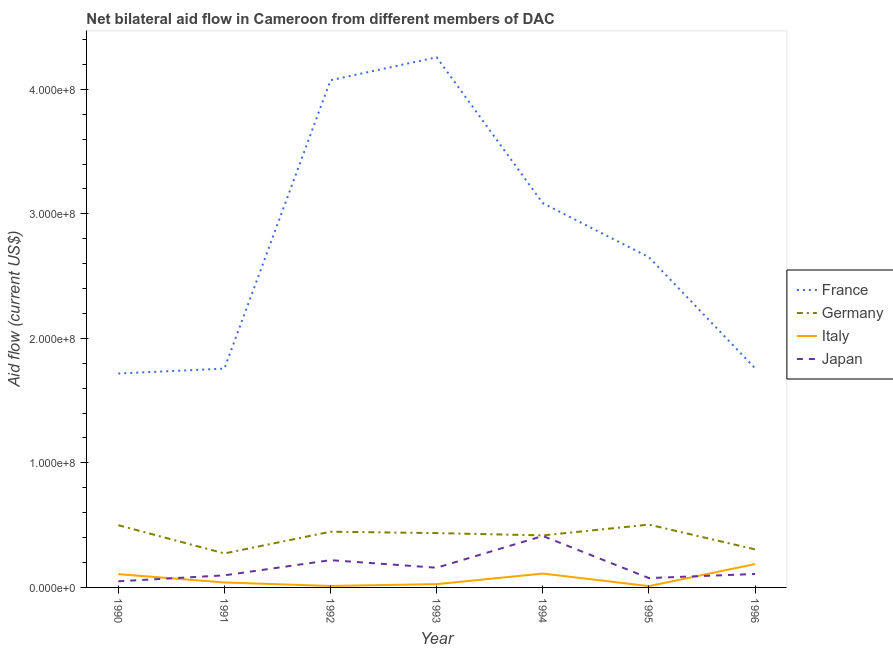How many different coloured lines are there?
Your answer should be very brief. 4. Does the line corresponding to amount of aid given by italy intersect with the line corresponding to amount of aid given by germany?
Your answer should be very brief. No. What is the amount of aid given by france in 1994?
Your response must be concise. 3.09e+08. Across all years, what is the maximum amount of aid given by france?
Offer a very short reply. 4.26e+08. Across all years, what is the minimum amount of aid given by france?
Keep it short and to the point. 1.72e+08. What is the total amount of aid given by france in the graph?
Your answer should be compact. 1.93e+09. What is the difference between the amount of aid given by france in 1991 and that in 1995?
Offer a very short reply. -8.94e+07. What is the difference between the amount of aid given by germany in 1992 and the amount of aid given by italy in 1995?
Provide a short and direct response. 4.37e+07. What is the average amount of aid given by italy per year?
Provide a short and direct response. 7.06e+06. In the year 1990, what is the difference between the amount of aid given by france and amount of aid given by japan?
Keep it short and to the point. 1.67e+08. In how many years, is the amount of aid given by japan greater than 360000000 US$?
Provide a short and direct response. 0. What is the ratio of the amount of aid given by japan in 1990 to that in 1995?
Offer a very short reply. 0.65. Is the difference between the amount of aid given by japan in 1990 and 1991 greater than the difference between the amount of aid given by france in 1990 and 1991?
Make the answer very short. No. What is the difference between the highest and the second highest amount of aid given by italy?
Make the answer very short. 7.63e+06. What is the difference between the highest and the lowest amount of aid given by france?
Give a very brief answer. 2.54e+08. Is the sum of the amount of aid given by france in 1990 and 1995 greater than the maximum amount of aid given by germany across all years?
Offer a very short reply. Yes. Is it the case that in every year, the sum of the amount of aid given by france and amount of aid given by germany is greater than the amount of aid given by italy?
Make the answer very short. Yes. Is the amount of aid given by france strictly greater than the amount of aid given by germany over the years?
Your answer should be very brief. Yes. Is the amount of aid given by france strictly less than the amount of aid given by italy over the years?
Make the answer very short. No. How many years are there in the graph?
Provide a short and direct response. 7. What is the difference between two consecutive major ticks on the Y-axis?
Ensure brevity in your answer.  1.00e+08. Where does the legend appear in the graph?
Ensure brevity in your answer.  Center right. How many legend labels are there?
Offer a terse response. 4. How are the legend labels stacked?
Your answer should be compact. Vertical. What is the title of the graph?
Your answer should be compact. Net bilateral aid flow in Cameroon from different members of DAC. Does "UNDP" appear as one of the legend labels in the graph?
Ensure brevity in your answer.  No. What is the label or title of the Y-axis?
Your answer should be very brief. Aid flow (current US$). What is the Aid flow (current US$) of France in 1990?
Your answer should be very brief. 1.72e+08. What is the Aid flow (current US$) in Germany in 1990?
Keep it short and to the point. 5.00e+07. What is the Aid flow (current US$) in Italy in 1990?
Your answer should be very brief. 1.07e+07. What is the Aid flow (current US$) of Japan in 1990?
Make the answer very short. 4.91e+06. What is the Aid flow (current US$) of France in 1991?
Give a very brief answer. 1.76e+08. What is the Aid flow (current US$) in Germany in 1991?
Provide a short and direct response. 2.73e+07. What is the Aid flow (current US$) in Italy in 1991?
Ensure brevity in your answer.  3.98e+06. What is the Aid flow (current US$) in Japan in 1991?
Offer a terse response. 9.71e+06. What is the Aid flow (current US$) in France in 1992?
Your answer should be very brief. 4.07e+08. What is the Aid flow (current US$) of Germany in 1992?
Your response must be concise. 4.47e+07. What is the Aid flow (current US$) of Italy in 1992?
Your answer should be very brief. 1.18e+06. What is the Aid flow (current US$) in Japan in 1992?
Your response must be concise. 2.19e+07. What is the Aid flow (current US$) in France in 1993?
Offer a terse response. 4.26e+08. What is the Aid flow (current US$) of Germany in 1993?
Offer a terse response. 4.36e+07. What is the Aid flow (current US$) of Italy in 1993?
Ensure brevity in your answer.  2.65e+06. What is the Aid flow (current US$) in Japan in 1993?
Provide a succinct answer. 1.58e+07. What is the Aid flow (current US$) of France in 1994?
Your answer should be compact. 3.09e+08. What is the Aid flow (current US$) of Germany in 1994?
Make the answer very short. 4.18e+07. What is the Aid flow (current US$) in Italy in 1994?
Your answer should be compact. 1.11e+07. What is the Aid flow (current US$) of Japan in 1994?
Provide a short and direct response. 4.13e+07. What is the Aid flow (current US$) in France in 1995?
Your answer should be very brief. 2.65e+08. What is the Aid flow (current US$) of Germany in 1995?
Your answer should be very brief. 5.04e+07. What is the Aid flow (current US$) of Italy in 1995?
Make the answer very short. 1.05e+06. What is the Aid flow (current US$) of Japan in 1995?
Your answer should be compact. 7.51e+06. What is the Aid flow (current US$) in France in 1996?
Provide a succinct answer. 1.76e+08. What is the Aid flow (current US$) in Germany in 1996?
Keep it short and to the point. 3.06e+07. What is the Aid flow (current US$) in Italy in 1996?
Your answer should be compact. 1.88e+07. What is the Aid flow (current US$) of Japan in 1996?
Make the answer very short. 1.08e+07. Across all years, what is the maximum Aid flow (current US$) in France?
Keep it short and to the point. 4.26e+08. Across all years, what is the maximum Aid flow (current US$) in Germany?
Keep it short and to the point. 5.04e+07. Across all years, what is the maximum Aid flow (current US$) of Italy?
Offer a terse response. 1.88e+07. Across all years, what is the maximum Aid flow (current US$) in Japan?
Offer a very short reply. 4.13e+07. Across all years, what is the minimum Aid flow (current US$) in France?
Your response must be concise. 1.72e+08. Across all years, what is the minimum Aid flow (current US$) of Germany?
Your answer should be compact. 2.73e+07. Across all years, what is the minimum Aid flow (current US$) in Italy?
Your answer should be very brief. 1.05e+06. Across all years, what is the minimum Aid flow (current US$) of Japan?
Provide a short and direct response. 4.91e+06. What is the total Aid flow (current US$) of France in the graph?
Ensure brevity in your answer.  1.93e+09. What is the total Aid flow (current US$) in Germany in the graph?
Offer a terse response. 2.88e+08. What is the total Aid flow (current US$) of Italy in the graph?
Provide a short and direct response. 4.94e+07. What is the total Aid flow (current US$) of Japan in the graph?
Make the answer very short. 1.12e+08. What is the difference between the Aid flow (current US$) in France in 1990 and that in 1991?
Ensure brevity in your answer.  -3.96e+06. What is the difference between the Aid flow (current US$) of Germany in 1990 and that in 1991?
Make the answer very short. 2.27e+07. What is the difference between the Aid flow (current US$) in Italy in 1990 and that in 1991?
Keep it short and to the point. 6.69e+06. What is the difference between the Aid flow (current US$) of Japan in 1990 and that in 1991?
Keep it short and to the point. -4.80e+06. What is the difference between the Aid flow (current US$) of France in 1990 and that in 1992?
Offer a terse response. -2.36e+08. What is the difference between the Aid flow (current US$) of Germany in 1990 and that in 1992?
Make the answer very short. 5.23e+06. What is the difference between the Aid flow (current US$) in Italy in 1990 and that in 1992?
Offer a terse response. 9.49e+06. What is the difference between the Aid flow (current US$) in Japan in 1990 and that in 1992?
Offer a terse response. -1.70e+07. What is the difference between the Aid flow (current US$) in France in 1990 and that in 1993?
Provide a short and direct response. -2.54e+08. What is the difference between the Aid flow (current US$) of Germany in 1990 and that in 1993?
Give a very brief answer. 6.34e+06. What is the difference between the Aid flow (current US$) of Italy in 1990 and that in 1993?
Make the answer very short. 8.02e+06. What is the difference between the Aid flow (current US$) in Japan in 1990 and that in 1993?
Ensure brevity in your answer.  -1.09e+07. What is the difference between the Aid flow (current US$) in France in 1990 and that in 1994?
Offer a terse response. -1.37e+08. What is the difference between the Aid flow (current US$) in Germany in 1990 and that in 1994?
Provide a short and direct response. 8.19e+06. What is the difference between the Aid flow (current US$) in Italy in 1990 and that in 1994?
Give a very brief answer. -4.50e+05. What is the difference between the Aid flow (current US$) in Japan in 1990 and that in 1994?
Your answer should be very brief. -3.64e+07. What is the difference between the Aid flow (current US$) in France in 1990 and that in 1995?
Your answer should be very brief. -9.34e+07. What is the difference between the Aid flow (current US$) of Germany in 1990 and that in 1995?
Ensure brevity in your answer.  -4.60e+05. What is the difference between the Aid flow (current US$) of Italy in 1990 and that in 1995?
Offer a very short reply. 9.62e+06. What is the difference between the Aid flow (current US$) in Japan in 1990 and that in 1995?
Your response must be concise. -2.60e+06. What is the difference between the Aid flow (current US$) in France in 1990 and that in 1996?
Provide a short and direct response. -4.25e+06. What is the difference between the Aid flow (current US$) of Germany in 1990 and that in 1996?
Your answer should be very brief. 1.94e+07. What is the difference between the Aid flow (current US$) in Italy in 1990 and that in 1996?
Your answer should be very brief. -8.08e+06. What is the difference between the Aid flow (current US$) of Japan in 1990 and that in 1996?
Keep it short and to the point. -5.88e+06. What is the difference between the Aid flow (current US$) in France in 1991 and that in 1992?
Ensure brevity in your answer.  -2.32e+08. What is the difference between the Aid flow (current US$) in Germany in 1991 and that in 1992?
Offer a terse response. -1.74e+07. What is the difference between the Aid flow (current US$) in Italy in 1991 and that in 1992?
Your answer should be very brief. 2.80e+06. What is the difference between the Aid flow (current US$) in Japan in 1991 and that in 1992?
Make the answer very short. -1.22e+07. What is the difference between the Aid flow (current US$) in France in 1991 and that in 1993?
Offer a very short reply. -2.50e+08. What is the difference between the Aid flow (current US$) of Germany in 1991 and that in 1993?
Your response must be concise. -1.63e+07. What is the difference between the Aid flow (current US$) of Italy in 1991 and that in 1993?
Your answer should be very brief. 1.33e+06. What is the difference between the Aid flow (current US$) in Japan in 1991 and that in 1993?
Ensure brevity in your answer.  -6.10e+06. What is the difference between the Aid flow (current US$) in France in 1991 and that in 1994?
Offer a very short reply. -1.33e+08. What is the difference between the Aid flow (current US$) of Germany in 1991 and that in 1994?
Your answer should be compact. -1.45e+07. What is the difference between the Aid flow (current US$) of Italy in 1991 and that in 1994?
Your answer should be compact. -7.14e+06. What is the difference between the Aid flow (current US$) of Japan in 1991 and that in 1994?
Provide a succinct answer. -3.16e+07. What is the difference between the Aid flow (current US$) of France in 1991 and that in 1995?
Keep it short and to the point. -8.94e+07. What is the difference between the Aid flow (current US$) in Germany in 1991 and that in 1995?
Give a very brief answer. -2.31e+07. What is the difference between the Aid flow (current US$) of Italy in 1991 and that in 1995?
Make the answer very short. 2.93e+06. What is the difference between the Aid flow (current US$) of Japan in 1991 and that in 1995?
Your response must be concise. 2.20e+06. What is the difference between the Aid flow (current US$) in France in 1991 and that in 1996?
Make the answer very short. -2.90e+05. What is the difference between the Aid flow (current US$) of Germany in 1991 and that in 1996?
Give a very brief answer. -3.27e+06. What is the difference between the Aid flow (current US$) of Italy in 1991 and that in 1996?
Make the answer very short. -1.48e+07. What is the difference between the Aid flow (current US$) in Japan in 1991 and that in 1996?
Offer a terse response. -1.08e+06. What is the difference between the Aid flow (current US$) in France in 1992 and that in 1993?
Provide a short and direct response. -1.84e+07. What is the difference between the Aid flow (current US$) of Germany in 1992 and that in 1993?
Ensure brevity in your answer.  1.11e+06. What is the difference between the Aid flow (current US$) in Italy in 1992 and that in 1993?
Ensure brevity in your answer.  -1.47e+06. What is the difference between the Aid flow (current US$) of Japan in 1992 and that in 1993?
Your answer should be compact. 6.09e+06. What is the difference between the Aid flow (current US$) in France in 1992 and that in 1994?
Your answer should be compact. 9.87e+07. What is the difference between the Aid flow (current US$) of Germany in 1992 and that in 1994?
Your answer should be very brief. 2.96e+06. What is the difference between the Aid flow (current US$) of Italy in 1992 and that in 1994?
Ensure brevity in your answer.  -9.94e+06. What is the difference between the Aid flow (current US$) of Japan in 1992 and that in 1994?
Keep it short and to the point. -1.94e+07. What is the difference between the Aid flow (current US$) of France in 1992 and that in 1995?
Offer a terse response. 1.42e+08. What is the difference between the Aid flow (current US$) of Germany in 1992 and that in 1995?
Offer a terse response. -5.69e+06. What is the difference between the Aid flow (current US$) of Japan in 1992 and that in 1995?
Provide a short and direct response. 1.44e+07. What is the difference between the Aid flow (current US$) of France in 1992 and that in 1996?
Your response must be concise. 2.31e+08. What is the difference between the Aid flow (current US$) in Germany in 1992 and that in 1996?
Provide a succinct answer. 1.42e+07. What is the difference between the Aid flow (current US$) of Italy in 1992 and that in 1996?
Your response must be concise. -1.76e+07. What is the difference between the Aid flow (current US$) in Japan in 1992 and that in 1996?
Make the answer very short. 1.11e+07. What is the difference between the Aid flow (current US$) of France in 1993 and that in 1994?
Keep it short and to the point. 1.17e+08. What is the difference between the Aid flow (current US$) in Germany in 1993 and that in 1994?
Give a very brief answer. 1.85e+06. What is the difference between the Aid flow (current US$) of Italy in 1993 and that in 1994?
Keep it short and to the point. -8.47e+06. What is the difference between the Aid flow (current US$) in Japan in 1993 and that in 1994?
Make the answer very short. -2.55e+07. What is the difference between the Aid flow (current US$) of France in 1993 and that in 1995?
Offer a terse response. 1.61e+08. What is the difference between the Aid flow (current US$) of Germany in 1993 and that in 1995?
Offer a very short reply. -6.80e+06. What is the difference between the Aid flow (current US$) in Italy in 1993 and that in 1995?
Offer a very short reply. 1.60e+06. What is the difference between the Aid flow (current US$) of Japan in 1993 and that in 1995?
Provide a short and direct response. 8.30e+06. What is the difference between the Aid flow (current US$) in France in 1993 and that in 1996?
Provide a short and direct response. 2.50e+08. What is the difference between the Aid flow (current US$) of Germany in 1993 and that in 1996?
Offer a terse response. 1.31e+07. What is the difference between the Aid flow (current US$) in Italy in 1993 and that in 1996?
Provide a succinct answer. -1.61e+07. What is the difference between the Aid flow (current US$) of Japan in 1993 and that in 1996?
Offer a very short reply. 5.02e+06. What is the difference between the Aid flow (current US$) of France in 1994 and that in 1995?
Your answer should be compact. 4.34e+07. What is the difference between the Aid flow (current US$) of Germany in 1994 and that in 1995?
Offer a terse response. -8.65e+06. What is the difference between the Aid flow (current US$) of Italy in 1994 and that in 1995?
Provide a short and direct response. 1.01e+07. What is the difference between the Aid flow (current US$) in Japan in 1994 and that in 1995?
Make the answer very short. 3.38e+07. What is the difference between the Aid flow (current US$) of France in 1994 and that in 1996?
Make the answer very short. 1.33e+08. What is the difference between the Aid flow (current US$) in Germany in 1994 and that in 1996?
Keep it short and to the point. 1.12e+07. What is the difference between the Aid flow (current US$) of Italy in 1994 and that in 1996?
Your answer should be very brief. -7.63e+06. What is the difference between the Aid flow (current US$) of Japan in 1994 and that in 1996?
Your answer should be very brief. 3.05e+07. What is the difference between the Aid flow (current US$) in France in 1995 and that in 1996?
Provide a short and direct response. 8.92e+07. What is the difference between the Aid flow (current US$) of Germany in 1995 and that in 1996?
Your answer should be very brief. 1.99e+07. What is the difference between the Aid flow (current US$) of Italy in 1995 and that in 1996?
Offer a terse response. -1.77e+07. What is the difference between the Aid flow (current US$) of Japan in 1995 and that in 1996?
Give a very brief answer. -3.28e+06. What is the difference between the Aid flow (current US$) of France in 1990 and the Aid flow (current US$) of Germany in 1991?
Keep it short and to the point. 1.44e+08. What is the difference between the Aid flow (current US$) of France in 1990 and the Aid flow (current US$) of Italy in 1991?
Provide a succinct answer. 1.68e+08. What is the difference between the Aid flow (current US$) in France in 1990 and the Aid flow (current US$) in Japan in 1991?
Provide a short and direct response. 1.62e+08. What is the difference between the Aid flow (current US$) of Germany in 1990 and the Aid flow (current US$) of Italy in 1991?
Your response must be concise. 4.60e+07. What is the difference between the Aid flow (current US$) of Germany in 1990 and the Aid flow (current US$) of Japan in 1991?
Keep it short and to the point. 4.03e+07. What is the difference between the Aid flow (current US$) of Italy in 1990 and the Aid flow (current US$) of Japan in 1991?
Give a very brief answer. 9.60e+05. What is the difference between the Aid flow (current US$) in France in 1990 and the Aid flow (current US$) in Germany in 1992?
Give a very brief answer. 1.27e+08. What is the difference between the Aid flow (current US$) of France in 1990 and the Aid flow (current US$) of Italy in 1992?
Your answer should be compact. 1.71e+08. What is the difference between the Aid flow (current US$) of France in 1990 and the Aid flow (current US$) of Japan in 1992?
Ensure brevity in your answer.  1.50e+08. What is the difference between the Aid flow (current US$) of Germany in 1990 and the Aid flow (current US$) of Italy in 1992?
Your response must be concise. 4.88e+07. What is the difference between the Aid flow (current US$) in Germany in 1990 and the Aid flow (current US$) in Japan in 1992?
Provide a succinct answer. 2.81e+07. What is the difference between the Aid flow (current US$) in Italy in 1990 and the Aid flow (current US$) in Japan in 1992?
Give a very brief answer. -1.12e+07. What is the difference between the Aid flow (current US$) of France in 1990 and the Aid flow (current US$) of Germany in 1993?
Offer a very short reply. 1.28e+08. What is the difference between the Aid flow (current US$) of France in 1990 and the Aid flow (current US$) of Italy in 1993?
Your answer should be very brief. 1.69e+08. What is the difference between the Aid flow (current US$) in France in 1990 and the Aid flow (current US$) in Japan in 1993?
Your answer should be very brief. 1.56e+08. What is the difference between the Aid flow (current US$) in Germany in 1990 and the Aid flow (current US$) in Italy in 1993?
Ensure brevity in your answer.  4.73e+07. What is the difference between the Aid flow (current US$) in Germany in 1990 and the Aid flow (current US$) in Japan in 1993?
Provide a succinct answer. 3.42e+07. What is the difference between the Aid flow (current US$) of Italy in 1990 and the Aid flow (current US$) of Japan in 1993?
Provide a short and direct response. -5.14e+06. What is the difference between the Aid flow (current US$) of France in 1990 and the Aid flow (current US$) of Germany in 1994?
Your response must be concise. 1.30e+08. What is the difference between the Aid flow (current US$) of France in 1990 and the Aid flow (current US$) of Italy in 1994?
Provide a short and direct response. 1.61e+08. What is the difference between the Aid flow (current US$) of France in 1990 and the Aid flow (current US$) of Japan in 1994?
Make the answer very short. 1.30e+08. What is the difference between the Aid flow (current US$) of Germany in 1990 and the Aid flow (current US$) of Italy in 1994?
Offer a very short reply. 3.88e+07. What is the difference between the Aid flow (current US$) of Germany in 1990 and the Aid flow (current US$) of Japan in 1994?
Your response must be concise. 8.65e+06. What is the difference between the Aid flow (current US$) in Italy in 1990 and the Aid flow (current US$) in Japan in 1994?
Keep it short and to the point. -3.06e+07. What is the difference between the Aid flow (current US$) in France in 1990 and the Aid flow (current US$) in Germany in 1995?
Ensure brevity in your answer.  1.21e+08. What is the difference between the Aid flow (current US$) of France in 1990 and the Aid flow (current US$) of Italy in 1995?
Offer a very short reply. 1.71e+08. What is the difference between the Aid flow (current US$) of France in 1990 and the Aid flow (current US$) of Japan in 1995?
Offer a very short reply. 1.64e+08. What is the difference between the Aid flow (current US$) in Germany in 1990 and the Aid flow (current US$) in Italy in 1995?
Provide a short and direct response. 4.89e+07. What is the difference between the Aid flow (current US$) in Germany in 1990 and the Aid flow (current US$) in Japan in 1995?
Your answer should be compact. 4.25e+07. What is the difference between the Aid flow (current US$) in Italy in 1990 and the Aid flow (current US$) in Japan in 1995?
Keep it short and to the point. 3.16e+06. What is the difference between the Aid flow (current US$) in France in 1990 and the Aid flow (current US$) in Germany in 1996?
Make the answer very short. 1.41e+08. What is the difference between the Aid flow (current US$) in France in 1990 and the Aid flow (current US$) in Italy in 1996?
Offer a very short reply. 1.53e+08. What is the difference between the Aid flow (current US$) in France in 1990 and the Aid flow (current US$) in Japan in 1996?
Offer a terse response. 1.61e+08. What is the difference between the Aid flow (current US$) of Germany in 1990 and the Aid flow (current US$) of Italy in 1996?
Provide a succinct answer. 3.12e+07. What is the difference between the Aid flow (current US$) of Germany in 1990 and the Aid flow (current US$) of Japan in 1996?
Provide a short and direct response. 3.92e+07. What is the difference between the Aid flow (current US$) of France in 1991 and the Aid flow (current US$) of Germany in 1992?
Provide a succinct answer. 1.31e+08. What is the difference between the Aid flow (current US$) in France in 1991 and the Aid flow (current US$) in Italy in 1992?
Your answer should be compact. 1.75e+08. What is the difference between the Aid flow (current US$) of France in 1991 and the Aid flow (current US$) of Japan in 1992?
Your answer should be very brief. 1.54e+08. What is the difference between the Aid flow (current US$) of Germany in 1991 and the Aid flow (current US$) of Italy in 1992?
Offer a terse response. 2.61e+07. What is the difference between the Aid flow (current US$) of Germany in 1991 and the Aid flow (current US$) of Japan in 1992?
Give a very brief answer. 5.39e+06. What is the difference between the Aid flow (current US$) in Italy in 1991 and the Aid flow (current US$) in Japan in 1992?
Provide a short and direct response. -1.79e+07. What is the difference between the Aid flow (current US$) of France in 1991 and the Aid flow (current US$) of Germany in 1993?
Provide a short and direct response. 1.32e+08. What is the difference between the Aid flow (current US$) of France in 1991 and the Aid flow (current US$) of Italy in 1993?
Ensure brevity in your answer.  1.73e+08. What is the difference between the Aid flow (current US$) of France in 1991 and the Aid flow (current US$) of Japan in 1993?
Your response must be concise. 1.60e+08. What is the difference between the Aid flow (current US$) in Germany in 1991 and the Aid flow (current US$) in Italy in 1993?
Offer a very short reply. 2.46e+07. What is the difference between the Aid flow (current US$) in Germany in 1991 and the Aid flow (current US$) in Japan in 1993?
Provide a succinct answer. 1.15e+07. What is the difference between the Aid flow (current US$) of Italy in 1991 and the Aid flow (current US$) of Japan in 1993?
Offer a very short reply. -1.18e+07. What is the difference between the Aid flow (current US$) in France in 1991 and the Aid flow (current US$) in Germany in 1994?
Ensure brevity in your answer.  1.34e+08. What is the difference between the Aid flow (current US$) in France in 1991 and the Aid flow (current US$) in Italy in 1994?
Offer a terse response. 1.65e+08. What is the difference between the Aid flow (current US$) of France in 1991 and the Aid flow (current US$) of Japan in 1994?
Keep it short and to the point. 1.34e+08. What is the difference between the Aid flow (current US$) of Germany in 1991 and the Aid flow (current US$) of Italy in 1994?
Give a very brief answer. 1.62e+07. What is the difference between the Aid flow (current US$) in Germany in 1991 and the Aid flow (current US$) in Japan in 1994?
Offer a very short reply. -1.40e+07. What is the difference between the Aid flow (current US$) in Italy in 1991 and the Aid flow (current US$) in Japan in 1994?
Provide a succinct answer. -3.73e+07. What is the difference between the Aid flow (current US$) in France in 1991 and the Aid flow (current US$) in Germany in 1995?
Ensure brevity in your answer.  1.25e+08. What is the difference between the Aid flow (current US$) in France in 1991 and the Aid flow (current US$) in Italy in 1995?
Offer a very short reply. 1.75e+08. What is the difference between the Aid flow (current US$) of France in 1991 and the Aid flow (current US$) of Japan in 1995?
Your answer should be compact. 1.68e+08. What is the difference between the Aid flow (current US$) in Germany in 1991 and the Aid flow (current US$) in Italy in 1995?
Provide a succinct answer. 2.62e+07. What is the difference between the Aid flow (current US$) of Germany in 1991 and the Aid flow (current US$) of Japan in 1995?
Your answer should be very brief. 1.98e+07. What is the difference between the Aid flow (current US$) in Italy in 1991 and the Aid flow (current US$) in Japan in 1995?
Offer a terse response. -3.53e+06. What is the difference between the Aid flow (current US$) of France in 1991 and the Aid flow (current US$) of Germany in 1996?
Provide a short and direct response. 1.45e+08. What is the difference between the Aid flow (current US$) in France in 1991 and the Aid flow (current US$) in Italy in 1996?
Your response must be concise. 1.57e+08. What is the difference between the Aid flow (current US$) in France in 1991 and the Aid flow (current US$) in Japan in 1996?
Your answer should be compact. 1.65e+08. What is the difference between the Aid flow (current US$) in Germany in 1991 and the Aid flow (current US$) in Italy in 1996?
Offer a terse response. 8.54e+06. What is the difference between the Aid flow (current US$) of Germany in 1991 and the Aid flow (current US$) of Japan in 1996?
Offer a very short reply. 1.65e+07. What is the difference between the Aid flow (current US$) in Italy in 1991 and the Aid flow (current US$) in Japan in 1996?
Offer a very short reply. -6.81e+06. What is the difference between the Aid flow (current US$) of France in 1992 and the Aid flow (current US$) of Germany in 1993?
Your answer should be compact. 3.64e+08. What is the difference between the Aid flow (current US$) of France in 1992 and the Aid flow (current US$) of Italy in 1993?
Your response must be concise. 4.05e+08. What is the difference between the Aid flow (current US$) of France in 1992 and the Aid flow (current US$) of Japan in 1993?
Offer a terse response. 3.91e+08. What is the difference between the Aid flow (current US$) of Germany in 1992 and the Aid flow (current US$) of Italy in 1993?
Your answer should be very brief. 4.21e+07. What is the difference between the Aid flow (current US$) of Germany in 1992 and the Aid flow (current US$) of Japan in 1993?
Your answer should be very brief. 2.89e+07. What is the difference between the Aid flow (current US$) in Italy in 1992 and the Aid flow (current US$) in Japan in 1993?
Offer a very short reply. -1.46e+07. What is the difference between the Aid flow (current US$) of France in 1992 and the Aid flow (current US$) of Germany in 1994?
Make the answer very short. 3.65e+08. What is the difference between the Aid flow (current US$) of France in 1992 and the Aid flow (current US$) of Italy in 1994?
Offer a very short reply. 3.96e+08. What is the difference between the Aid flow (current US$) of France in 1992 and the Aid flow (current US$) of Japan in 1994?
Offer a terse response. 3.66e+08. What is the difference between the Aid flow (current US$) in Germany in 1992 and the Aid flow (current US$) in Italy in 1994?
Keep it short and to the point. 3.36e+07. What is the difference between the Aid flow (current US$) in Germany in 1992 and the Aid flow (current US$) in Japan in 1994?
Provide a succinct answer. 3.42e+06. What is the difference between the Aid flow (current US$) in Italy in 1992 and the Aid flow (current US$) in Japan in 1994?
Your answer should be compact. -4.01e+07. What is the difference between the Aid flow (current US$) in France in 1992 and the Aid flow (current US$) in Germany in 1995?
Provide a short and direct response. 3.57e+08. What is the difference between the Aid flow (current US$) of France in 1992 and the Aid flow (current US$) of Italy in 1995?
Your answer should be compact. 4.06e+08. What is the difference between the Aid flow (current US$) in France in 1992 and the Aid flow (current US$) in Japan in 1995?
Ensure brevity in your answer.  4.00e+08. What is the difference between the Aid flow (current US$) in Germany in 1992 and the Aid flow (current US$) in Italy in 1995?
Offer a very short reply. 4.37e+07. What is the difference between the Aid flow (current US$) of Germany in 1992 and the Aid flow (current US$) of Japan in 1995?
Offer a very short reply. 3.72e+07. What is the difference between the Aid flow (current US$) in Italy in 1992 and the Aid flow (current US$) in Japan in 1995?
Provide a succinct answer. -6.33e+06. What is the difference between the Aid flow (current US$) in France in 1992 and the Aid flow (current US$) in Germany in 1996?
Your answer should be compact. 3.77e+08. What is the difference between the Aid flow (current US$) of France in 1992 and the Aid flow (current US$) of Italy in 1996?
Ensure brevity in your answer.  3.89e+08. What is the difference between the Aid flow (current US$) of France in 1992 and the Aid flow (current US$) of Japan in 1996?
Your answer should be compact. 3.96e+08. What is the difference between the Aid flow (current US$) in Germany in 1992 and the Aid flow (current US$) in Italy in 1996?
Ensure brevity in your answer.  2.60e+07. What is the difference between the Aid flow (current US$) in Germany in 1992 and the Aid flow (current US$) in Japan in 1996?
Your answer should be very brief. 3.40e+07. What is the difference between the Aid flow (current US$) of Italy in 1992 and the Aid flow (current US$) of Japan in 1996?
Provide a succinct answer. -9.61e+06. What is the difference between the Aid flow (current US$) in France in 1993 and the Aid flow (current US$) in Germany in 1994?
Make the answer very short. 3.84e+08. What is the difference between the Aid flow (current US$) of France in 1993 and the Aid flow (current US$) of Italy in 1994?
Your answer should be compact. 4.15e+08. What is the difference between the Aid flow (current US$) of France in 1993 and the Aid flow (current US$) of Japan in 1994?
Give a very brief answer. 3.84e+08. What is the difference between the Aid flow (current US$) in Germany in 1993 and the Aid flow (current US$) in Italy in 1994?
Your response must be concise. 3.25e+07. What is the difference between the Aid flow (current US$) in Germany in 1993 and the Aid flow (current US$) in Japan in 1994?
Your answer should be very brief. 2.31e+06. What is the difference between the Aid flow (current US$) of Italy in 1993 and the Aid flow (current US$) of Japan in 1994?
Your response must be concise. -3.87e+07. What is the difference between the Aid flow (current US$) of France in 1993 and the Aid flow (current US$) of Germany in 1995?
Offer a very short reply. 3.75e+08. What is the difference between the Aid flow (current US$) of France in 1993 and the Aid flow (current US$) of Italy in 1995?
Your answer should be very brief. 4.25e+08. What is the difference between the Aid flow (current US$) in France in 1993 and the Aid flow (current US$) in Japan in 1995?
Offer a very short reply. 4.18e+08. What is the difference between the Aid flow (current US$) of Germany in 1993 and the Aid flow (current US$) of Italy in 1995?
Your answer should be compact. 4.26e+07. What is the difference between the Aid flow (current US$) of Germany in 1993 and the Aid flow (current US$) of Japan in 1995?
Keep it short and to the point. 3.61e+07. What is the difference between the Aid flow (current US$) of Italy in 1993 and the Aid flow (current US$) of Japan in 1995?
Ensure brevity in your answer.  -4.86e+06. What is the difference between the Aid flow (current US$) in France in 1993 and the Aid flow (current US$) in Germany in 1996?
Offer a very short reply. 3.95e+08. What is the difference between the Aid flow (current US$) of France in 1993 and the Aid flow (current US$) of Italy in 1996?
Provide a succinct answer. 4.07e+08. What is the difference between the Aid flow (current US$) in France in 1993 and the Aid flow (current US$) in Japan in 1996?
Your response must be concise. 4.15e+08. What is the difference between the Aid flow (current US$) of Germany in 1993 and the Aid flow (current US$) of Italy in 1996?
Provide a short and direct response. 2.49e+07. What is the difference between the Aid flow (current US$) of Germany in 1993 and the Aid flow (current US$) of Japan in 1996?
Give a very brief answer. 3.28e+07. What is the difference between the Aid flow (current US$) in Italy in 1993 and the Aid flow (current US$) in Japan in 1996?
Your answer should be very brief. -8.14e+06. What is the difference between the Aid flow (current US$) in France in 1994 and the Aid flow (current US$) in Germany in 1995?
Your answer should be very brief. 2.58e+08. What is the difference between the Aid flow (current US$) in France in 1994 and the Aid flow (current US$) in Italy in 1995?
Offer a very short reply. 3.08e+08. What is the difference between the Aid flow (current US$) in France in 1994 and the Aid flow (current US$) in Japan in 1995?
Make the answer very short. 3.01e+08. What is the difference between the Aid flow (current US$) in Germany in 1994 and the Aid flow (current US$) in Italy in 1995?
Ensure brevity in your answer.  4.07e+07. What is the difference between the Aid flow (current US$) of Germany in 1994 and the Aid flow (current US$) of Japan in 1995?
Your response must be concise. 3.43e+07. What is the difference between the Aid flow (current US$) of Italy in 1994 and the Aid flow (current US$) of Japan in 1995?
Your answer should be very brief. 3.61e+06. What is the difference between the Aid flow (current US$) of France in 1994 and the Aid flow (current US$) of Germany in 1996?
Ensure brevity in your answer.  2.78e+08. What is the difference between the Aid flow (current US$) of France in 1994 and the Aid flow (current US$) of Italy in 1996?
Your answer should be compact. 2.90e+08. What is the difference between the Aid flow (current US$) of France in 1994 and the Aid flow (current US$) of Japan in 1996?
Provide a succinct answer. 2.98e+08. What is the difference between the Aid flow (current US$) of Germany in 1994 and the Aid flow (current US$) of Italy in 1996?
Keep it short and to the point. 2.30e+07. What is the difference between the Aid flow (current US$) of Germany in 1994 and the Aid flow (current US$) of Japan in 1996?
Offer a terse response. 3.10e+07. What is the difference between the Aid flow (current US$) of France in 1995 and the Aid flow (current US$) of Germany in 1996?
Your answer should be very brief. 2.35e+08. What is the difference between the Aid flow (current US$) in France in 1995 and the Aid flow (current US$) in Italy in 1996?
Your answer should be compact. 2.46e+08. What is the difference between the Aid flow (current US$) in France in 1995 and the Aid flow (current US$) in Japan in 1996?
Your response must be concise. 2.54e+08. What is the difference between the Aid flow (current US$) in Germany in 1995 and the Aid flow (current US$) in Italy in 1996?
Offer a terse response. 3.17e+07. What is the difference between the Aid flow (current US$) of Germany in 1995 and the Aid flow (current US$) of Japan in 1996?
Give a very brief answer. 3.96e+07. What is the difference between the Aid flow (current US$) of Italy in 1995 and the Aid flow (current US$) of Japan in 1996?
Your response must be concise. -9.74e+06. What is the average Aid flow (current US$) of France per year?
Provide a succinct answer. 2.76e+08. What is the average Aid flow (current US$) in Germany per year?
Ensure brevity in your answer.  4.12e+07. What is the average Aid flow (current US$) in Italy per year?
Your answer should be very brief. 7.06e+06. What is the average Aid flow (current US$) in Japan per year?
Keep it short and to the point. 1.60e+07. In the year 1990, what is the difference between the Aid flow (current US$) in France and Aid flow (current US$) in Germany?
Provide a short and direct response. 1.22e+08. In the year 1990, what is the difference between the Aid flow (current US$) of France and Aid flow (current US$) of Italy?
Your answer should be compact. 1.61e+08. In the year 1990, what is the difference between the Aid flow (current US$) of France and Aid flow (current US$) of Japan?
Provide a short and direct response. 1.67e+08. In the year 1990, what is the difference between the Aid flow (current US$) in Germany and Aid flow (current US$) in Italy?
Your answer should be very brief. 3.93e+07. In the year 1990, what is the difference between the Aid flow (current US$) of Germany and Aid flow (current US$) of Japan?
Offer a terse response. 4.51e+07. In the year 1990, what is the difference between the Aid flow (current US$) in Italy and Aid flow (current US$) in Japan?
Ensure brevity in your answer.  5.76e+06. In the year 1991, what is the difference between the Aid flow (current US$) in France and Aid flow (current US$) in Germany?
Provide a succinct answer. 1.48e+08. In the year 1991, what is the difference between the Aid flow (current US$) of France and Aid flow (current US$) of Italy?
Keep it short and to the point. 1.72e+08. In the year 1991, what is the difference between the Aid flow (current US$) of France and Aid flow (current US$) of Japan?
Offer a very short reply. 1.66e+08. In the year 1991, what is the difference between the Aid flow (current US$) in Germany and Aid flow (current US$) in Italy?
Provide a short and direct response. 2.33e+07. In the year 1991, what is the difference between the Aid flow (current US$) of Germany and Aid flow (current US$) of Japan?
Give a very brief answer. 1.76e+07. In the year 1991, what is the difference between the Aid flow (current US$) of Italy and Aid flow (current US$) of Japan?
Give a very brief answer. -5.73e+06. In the year 1992, what is the difference between the Aid flow (current US$) in France and Aid flow (current US$) in Germany?
Provide a short and direct response. 3.63e+08. In the year 1992, what is the difference between the Aid flow (current US$) of France and Aid flow (current US$) of Italy?
Keep it short and to the point. 4.06e+08. In the year 1992, what is the difference between the Aid flow (current US$) of France and Aid flow (current US$) of Japan?
Your answer should be compact. 3.85e+08. In the year 1992, what is the difference between the Aid flow (current US$) of Germany and Aid flow (current US$) of Italy?
Make the answer very short. 4.36e+07. In the year 1992, what is the difference between the Aid flow (current US$) in Germany and Aid flow (current US$) in Japan?
Give a very brief answer. 2.28e+07. In the year 1992, what is the difference between the Aid flow (current US$) of Italy and Aid flow (current US$) of Japan?
Ensure brevity in your answer.  -2.07e+07. In the year 1993, what is the difference between the Aid flow (current US$) of France and Aid flow (current US$) of Germany?
Make the answer very short. 3.82e+08. In the year 1993, what is the difference between the Aid flow (current US$) of France and Aid flow (current US$) of Italy?
Your answer should be very brief. 4.23e+08. In the year 1993, what is the difference between the Aid flow (current US$) in France and Aid flow (current US$) in Japan?
Offer a terse response. 4.10e+08. In the year 1993, what is the difference between the Aid flow (current US$) in Germany and Aid flow (current US$) in Italy?
Your answer should be compact. 4.10e+07. In the year 1993, what is the difference between the Aid flow (current US$) of Germany and Aid flow (current US$) of Japan?
Offer a very short reply. 2.78e+07. In the year 1993, what is the difference between the Aid flow (current US$) of Italy and Aid flow (current US$) of Japan?
Provide a short and direct response. -1.32e+07. In the year 1994, what is the difference between the Aid flow (current US$) in France and Aid flow (current US$) in Germany?
Provide a succinct answer. 2.67e+08. In the year 1994, what is the difference between the Aid flow (current US$) in France and Aid flow (current US$) in Italy?
Ensure brevity in your answer.  2.97e+08. In the year 1994, what is the difference between the Aid flow (current US$) of France and Aid flow (current US$) of Japan?
Provide a short and direct response. 2.67e+08. In the year 1994, what is the difference between the Aid flow (current US$) of Germany and Aid flow (current US$) of Italy?
Give a very brief answer. 3.07e+07. In the year 1994, what is the difference between the Aid flow (current US$) in Germany and Aid flow (current US$) in Japan?
Keep it short and to the point. 4.60e+05. In the year 1994, what is the difference between the Aid flow (current US$) of Italy and Aid flow (current US$) of Japan?
Provide a short and direct response. -3.02e+07. In the year 1995, what is the difference between the Aid flow (current US$) of France and Aid flow (current US$) of Germany?
Your response must be concise. 2.15e+08. In the year 1995, what is the difference between the Aid flow (current US$) in France and Aid flow (current US$) in Italy?
Your answer should be very brief. 2.64e+08. In the year 1995, what is the difference between the Aid flow (current US$) in France and Aid flow (current US$) in Japan?
Provide a succinct answer. 2.58e+08. In the year 1995, what is the difference between the Aid flow (current US$) in Germany and Aid flow (current US$) in Italy?
Your answer should be compact. 4.94e+07. In the year 1995, what is the difference between the Aid flow (current US$) in Germany and Aid flow (current US$) in Japan?
Ensure brevity in your answer.  4.29e+07. In the year 1995, what is the difference between the Aid flow (current US$) in Italy and Aid flow (current US$) in Japan?
Make the answer very short. -6.46e+06. In the year 1996, what is the difference between the Aid flow (current US$) in France and Aid flow (current US$) in Germany?
Give a very brief answer. 1.45e+08. In the year 1996, what is the difference between the Aid flow (current US$) in France and Aid flow (current US$) in Italy?
Your answer should be very brief. 1.57e+08. In the year 1996, what is the difference between the Aid flow (current US$) in France and Aid flow (current US$) in Japan?
Keep it short and to the point. 1.65e+08. In the year 1996, what is the difference between the Aid flow (current US$) of Germany and Aid flow (current US$) of Italy?
Make the answer very short. 1.18e+07. In the year 1996, what is the difference between the Aid flow (current US$) of Germany and Aid flow (current US$) of Japan?
Ensure brevity in your answer.  1.98e+07. In the year 1996, what is the difference between the Aid flow (current US$) in Italy and Aid flow (current US$) in Japan?
Your answer should be very brief. 7.96e+06. What is the ratio of the Aid flow (current US$) of France in 1990 to that in 1991?
Offer a terse response. 0.98. What is the ratio of the Aid flow (current US$) in Germany in 1990 to that in 1991?
Ensure brevity in your answer.  1.83. What is the ratio of the Aid flow (current US$) of Italy in 1990 to that in 1991?
Give a very brief answer. 2.68. What is the ratio of the Aid flow (current US$) of Japan in 1990 to that in 1991?
Offer a very short reply. 0.51. What is the ratio of the Aid flow (current US$) of France in 1990 to that in 1992?
Keep it short and to the point. 0.42. What is the ratio of the Aid flow (current US$) in Germany in 1990 to that in 1992?
Ensure brevity in your answer.  1.12. What is the ratio of the Aid flow (current US$) in Italy in 1990 to that in 1992?
Provide a short and direct response. 9.04. What is the ratio of the Aid flow (current US$) of Japan in 1990 to that in 1992?
Ensure brevity in your answer.  0.22. What is the ratio of the Aid flow (current US$) in France in 1990 to that in 1993?
Provide a succinct answer. 0.4. What is the ratio of the Aid flow (current US$) of Germany in 1990 to that in 1993?
Offer a terse response. 1.15. What is the ratio of the Aid flow (current US$) in Italy in 1990 to that in 1993?
Ensure brevity in your answer.  4.03. What is the ratio of the Aid flow (current US$) of Japan in 1990 to that in 1993?
Your answer should be compact. 0.31. What is the ratio of the Aid flow (current US$) of France in 1990 to that in 1994?
Offer a very short reply. 0.56. What is the ratio of the Aid flow (current US$) in Germany in 1990 to that in 1994?
Provide a short and direct response. 1.2. What is the ratio of the Aid flow (current US$) of Italy in 1990 to that in 1994?
Keep it short and to the point. 0.96. What is the ratio of the Aid flow (current US$) of Japan in 1990 to that in 1994?
Provide a succinct answer. 0.12. What is the ratio of the Aid flow (current US$) of France in 1990 to that in 1995?
Your answer should be very brief. 0.65. What is the ratio of the Aid flow (current US$) of Germany in 1990 to that in 1995?
Offer a very short reply. 0.99. What is the ratio of the Aid flow (current US$) of Italy in 1990 to that in 1995?
Provide a succinct answer. 10.16. What is the ratio of the Aid flow (current US$) of Japan in 1990 to that in 1995?
Offer a very short reply. 0.65. What is the ratio of the Aid flow (current US$) of France in 1990 to that in 1996?
Offer a very short reply. 0.98. What is the ratio of the Aid flow (current US$) of Germany in 1990 to that in 1996?
Your response must be concise. 1.64. What is the ratio of the Aid flow (current US$) of Italy in 1990 to that in 1996?
Your answer should be very brief. 0.57. What is the ratio of the Aid flow (current US$) in Japan in 1990 to that in 1996?
Your answer should be compact. 0.46. What is the ratio of the Aid flow (current US$) of France in 1991 to that in 1992?
Provide a succinct answer. 0.43. What is the ratio of the Aid flow (current US$) in Germany in 1991 to that in 1992?
Offer a terse response. 0.61. What is the ratio of the Aid flow (current US$) of Italy in 1991 to that in 1992?
Your answer should be compact. 3.37. What is the ratio of the Aid flow (current US$) of Japan in 1991 to that in 1992?
Offer a very short reply. 0.44. What is the ratio of the Aid flow (current US$) in France in 1991 to that in 1993?
Your answer should be very brief. 0.41. What is the ratio of the Aid flow (current US$) in Germany in 1991 to that in 1993?
Make the answer very short. 0.63. What is the ratio of the Aid flow (current US$) in Italy in 1991 to that in 1993?
Give a very brief answer. 1.5. What is the ratio of the Aid flow (current US$) of Japan in 1991 to that in 1993?
Ensure brevity in your answer.  0.61. What is the ratio of the Aid flow (current US$) in France in 1991 to that in 1994?
Your answer should be compact. 0.57. What is the ratio of the Aid flow (current US$) in Germany in 1991 to that in 1994?
Your response must be concise. 0.65. What is the ratio of the Aid flow (current US$) of Italy in 1991 to that in 1994?
Your answer should be very brief. 0.36. What is the ratio of the Aid flow (current US$) of Japan in 1991 to that in 1994?
Provide a succinct answer. 0.23. What is the ratio of the Aid flow (current US$) of France in 1991 to that in 1995?
Provide a short and direct response. 0.66. What is the ratio of the Aid flow (current US$) of Germany in 1991 to that in 1995?
Provide a short and direct response. 0.54. What is the ratio of the Aid flow (current US$) in Italy in 1991 to that in 1995?
Your response must be concise. 3.79. What is the ratio of the Aid flow (current US$) of Japan in 1991 to that in 1995?
Your answer should be very brief. 1.29. What is the ratio of the Aid flow (current US$) in France in 1991 to that in 1996?
Make the answer very short. 1. What is the ratio of the Aid flow (current US$) of Germany in 1991 to that in 1996?
Your response must be concise. 0.89. What is the ratio of the Aid flow (current US$) of Italy in 1991 to that in 1996?
Your response must be concise. 0.21. What is the ratio of the Aid flow (current US$) of Japan in 1991 to that in 1996?
Make the answer very short. 0.9. What is the ratio of the Aid flow (current US$) of France in 1992 to that in 1993?
Your answer should be very brief. 0.96. What is the ratio of the Aid flow (current US$) in Germany in 1992 to that in 1993?
Provide a succinct answer. 1.03. What is the ratio of the Aid flow (current US$) in Italy in 1992 to that in 1993?
Your response must be concise. 0.45. What is the ratio of the Aid flow (current US$) in Japan in 1992 to that in 1993?
Make the answer very short. 1.39. What is the ratio of the Aid flow (current US$) of France in 1992 to that in 1994?
Ensure brevity in your answer.  1.32. What is the ratio of the Aid flow (current US$) in Germany in 1992 to that in 1994?
Offer a very short reply. 1.07. What is the ratio of the Aid flow (current US$) of Italy in 1992 to that in 1994?
Provide a succinct answer. 0.11. What is the ratio of the Aid flow (current US$) of Japan in 1992 to that in 1994?
Provide a short and direct response. 0.53. What is the ratio of the Aid flow (current US$) in France in 1992 to that in 1995?
Keep it short and to the point. 1.54. What is the ratio of the Aid flow (current US$) of Germany in 1992 to that in 1995?
Offer a very short reply. 0.89. What is the ratio of the Aid flow (current US$) in Italy in 1992 to that in 1995?
Your answer should be very brief. 1.12. What is the ratio of the Aid flow (current US$) in Japan in 1992 to that in 1995?
Ensure brevity in your answer.  2.92. What is the ratio of the Aid flow (current US$) of France in 1992 to that in 1996?
Provide a succinct answer. 2.31. What is the ratio of the Aid flow (current US$) in Germany in 1992 to that in 1996?
Offer a very short reply. 1.46. What is the ratio of the Aid flow (current US$) of Italy in 1992 to that in 1996?
Your answer should be very brief. 0.06. What is the ratio of the Aid flow (current US$) of Japan in 1992 to that in 1996?
Ensure brevity in your answer.  2.03. What is the ratio of the Aid flow (current US$) in France in 1993 to that in 1994?
Keep it short and to the point. 1.38. What is the ratio of the Aid flow (current US$) in Germany in 1993 to that in 1994?
Keep it short and to the point. 1.04. What is the ratio of the Aid flow (current US$) of Italy in 1993 to that in 1994?
Offer a very short reply. 0.24. What is the ratio of the Aid flow (current US$) of Japan in 1993 to that in 1994?
Offer a very short reply. 0.38. What is the ratio of the Aid flow (current US$) in France in 1993 to that in 1995?
Your answer should be compact. 1.61. What is the ratio of the Aid flow (current US$) in Germany in 1993 to that in 1995?
Make the answer very short. 0.87. What is the ratio of the Aid flow (current US$) in Italy in 1993 to that in 1995?
Keep it short and to the point. 2.52. What is the ratio of the Aid flow (current US$) in Japan in 1993 to that in 1995?
Give a very brief answer. 2.11. What is the ratio of the Aid flow (current US$) in France in 1993 to that in 1996?
Your response must be concise. 2.42. What is the ratio of the Aid flow (current US$) in Germany in 1993 to that in 1996?
Offer a terse response. 1.43. What is the ratio of the Aid flow (current US$) of Italy in 1993 to that in 1996?
Your answer should be very brief. 0.14. What is the ratio of the Aid flow (current US$) of Japan in 1993 to that in 1996?
Provide a short and direct response. 1.47. What is the ratio of the Aid flow (current US$) of France in 1994 to that in 1995?
Give a very brief answer. 1.16. What is the ratio of the Aid flow (current US$) of Germany in 1994 to that in 1995?
Make the answer very short. 0.83. What is the ratio of the Aid flow (current US$) in Italy in 1994 to that in 1995?
Give a very brief answer. 10.59. What is the ratio of the Aid flow (current US$) of Japan in 1994 to that in 1995?
Your answer should be very brief. 5.5. What is the ratio of the Aid flow (current US$) of France in 1994 to that in 1996?
Your response must be concise. 1.75. What is the ratio of the Aid flow (current US$) of Germany in 1994 to that in 1996?
Offer a terse response. 1.37. What is the ratio of the Aid flow (current US$) in Italy in 1994 to that in 1996?
Your answer should be very brief. 0.59. What is the ratio of the Aid flow (current US$) in Japan in 1994 to that in 1996?
Keep it short and to the point. 3.83. What is the ratio of the Aid flow (current US$) of France in 1995 to that in 1996?
Provide a succinct answer. 1.51. What is the ratio of the Aid flow (current US$) in Germany in 1995 to that in 1996?
Provide a succinct answer. 1.65. What is the ratio of the Aid flow (current US$) of Italy in 1995 to that in 1996?
Give a very brief answer. 0.06. What is the ratio of the Aid flow (current US$) of Japan in 1995 to that in 1996?
Your answer should be very brief. 0.7. What is the difference between the highest and the second highest Aid flow (current US$) in France?
Keep it short and to the point. 1.84e+07. What is the difference between the highest and the second highest Aid flow (current US$) in Italy?
Make the answer very short. 7.63e+06. What is the difference between the highest and the second highest Aid flow (current US$) in Japan?
Offer a terse response. 1.94e+07. What is the difference between the highest and the lowest Aid flow (current US$) of France?
Keep it short and to the point. 2.54e+08. What is the difference between the highest and the lowest Aid flow (current US$) in Germany?
Offer a very short reply. 2.31e+07. What is the difference between the highest and the lowest Aid flow (current US$) of Italy?
Ensure brevity in your answer.  1.77e+07. What is the difference between the highest and the lowest Aid flow (current US$) of Japan?
Give a very brief answer. 3.64e+07. 